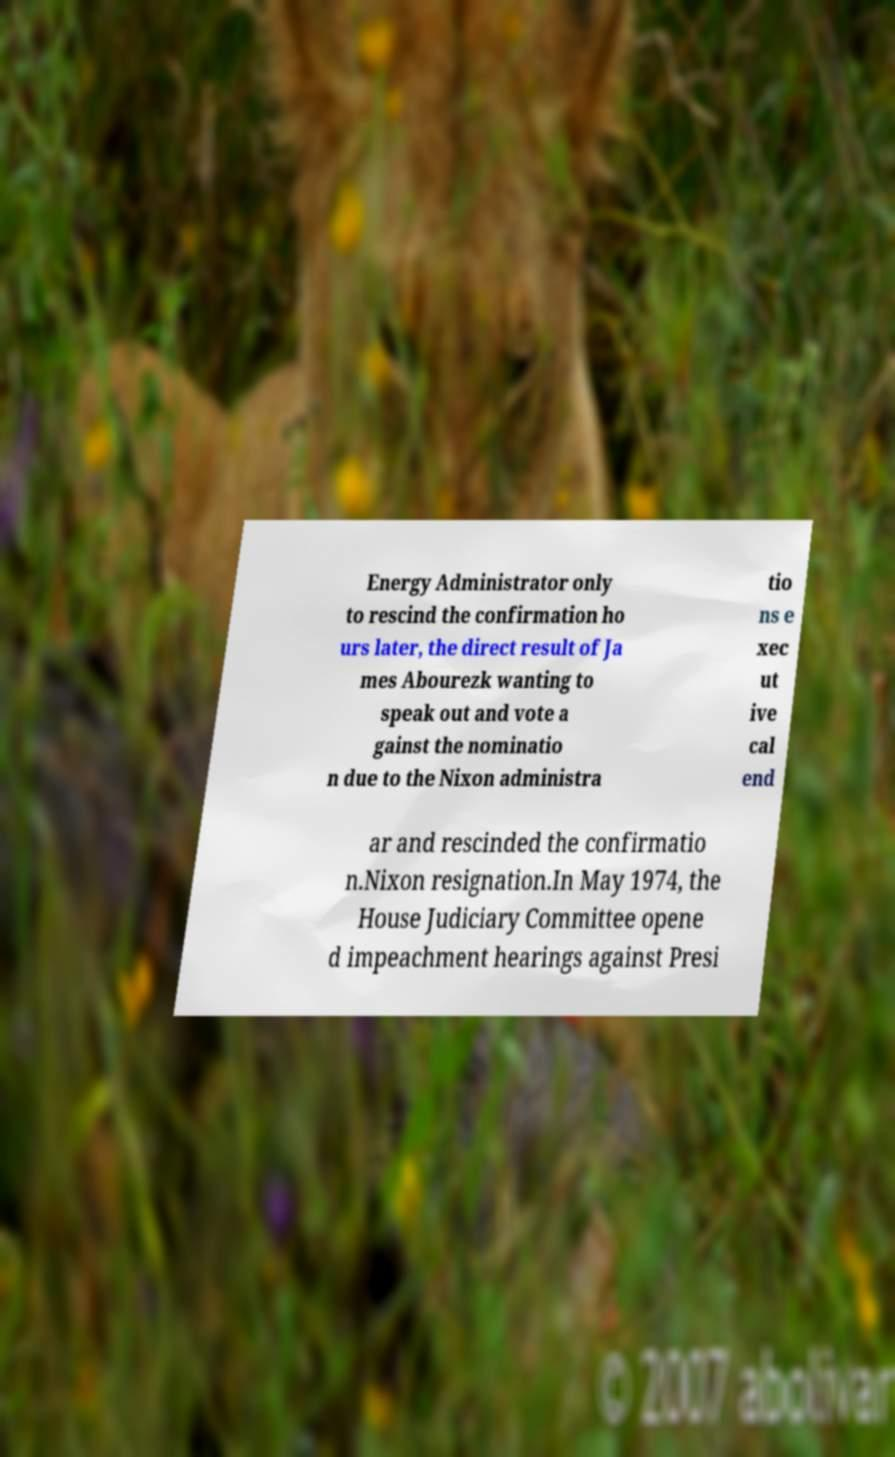Could you extract and type out the text from this image? Energy Administrator only to rescind the confirmation ho urs later, the direct result of Ja mes Abourezk wanting to speak out and vote a gainst the nominatio n due to the Nixon administra tio ns e xec ut ive cal end ar and rescinded the confirmatio n.Nixon resignation.In May 1974, the House Judiciary Committee opene d impeachment hearings against Presi 